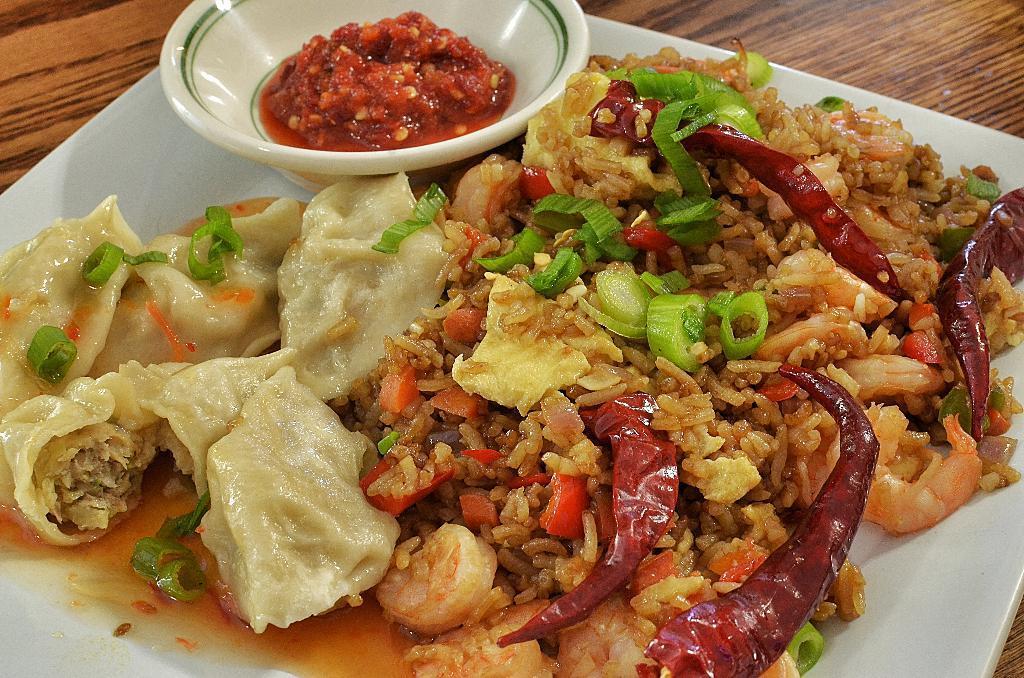Could you give a brief overview of what you see in this image? There is a white plate on a wooden table. On the plate there is a food item and bowl with food item. On the food item there are prawns, chilies and many other things. 